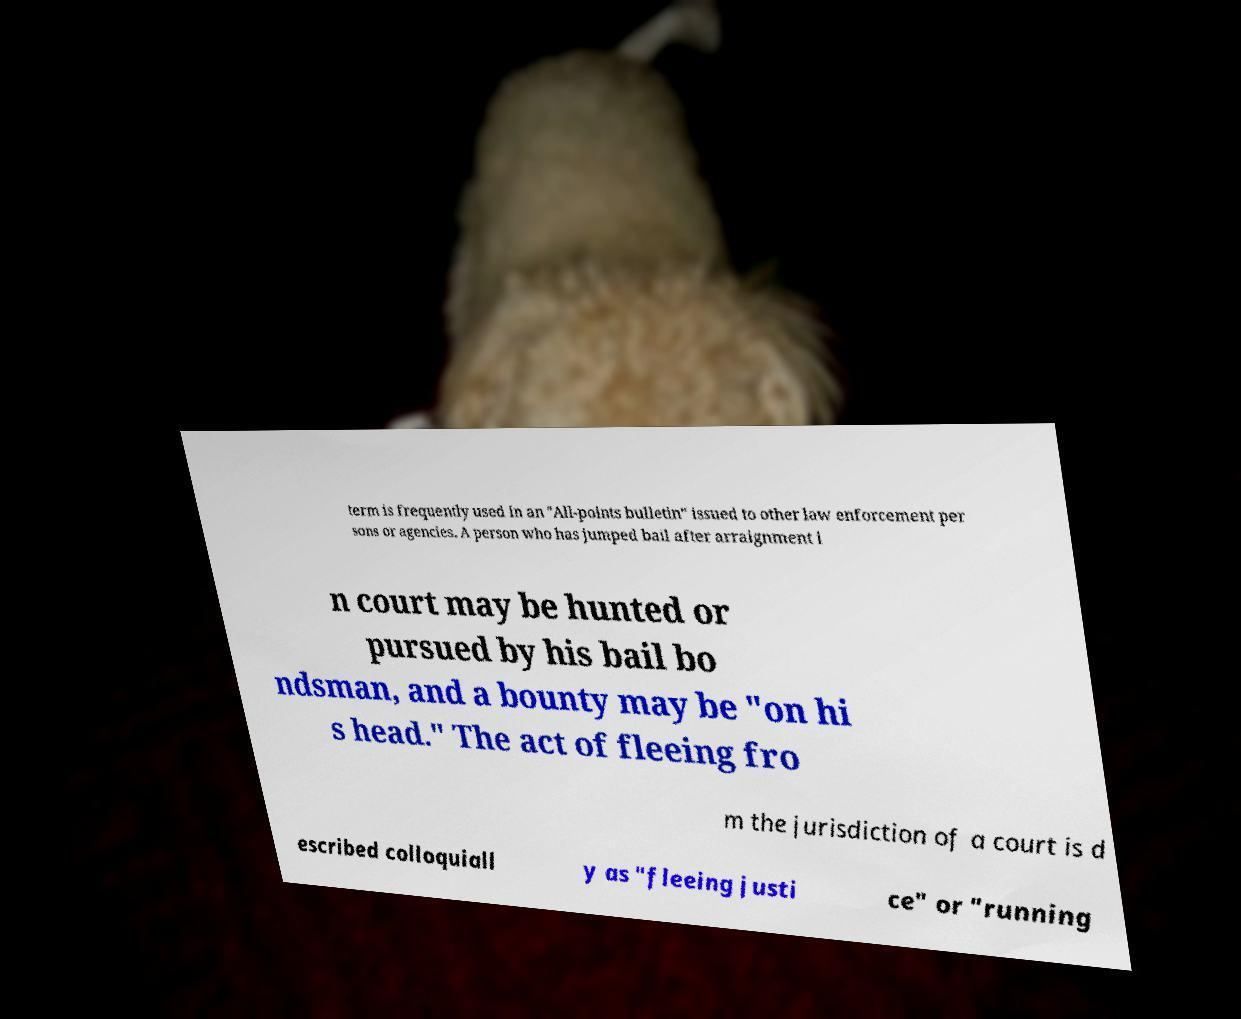There's text embedded in this image that I need extracted. Can you transcribe it verbatim? term is frequently used in an "All-points bulletin" issued to other law enforcement per sons or agencies. A person who has jumped bail after arraignment i n court may be hunted or pursued by his bail bo ndsman, and a bounty may be "on hi s head." The act of fleeing fro m the jurisdiction of a court is d escribed colloquiall y as "fleeing justi ce" or "running 